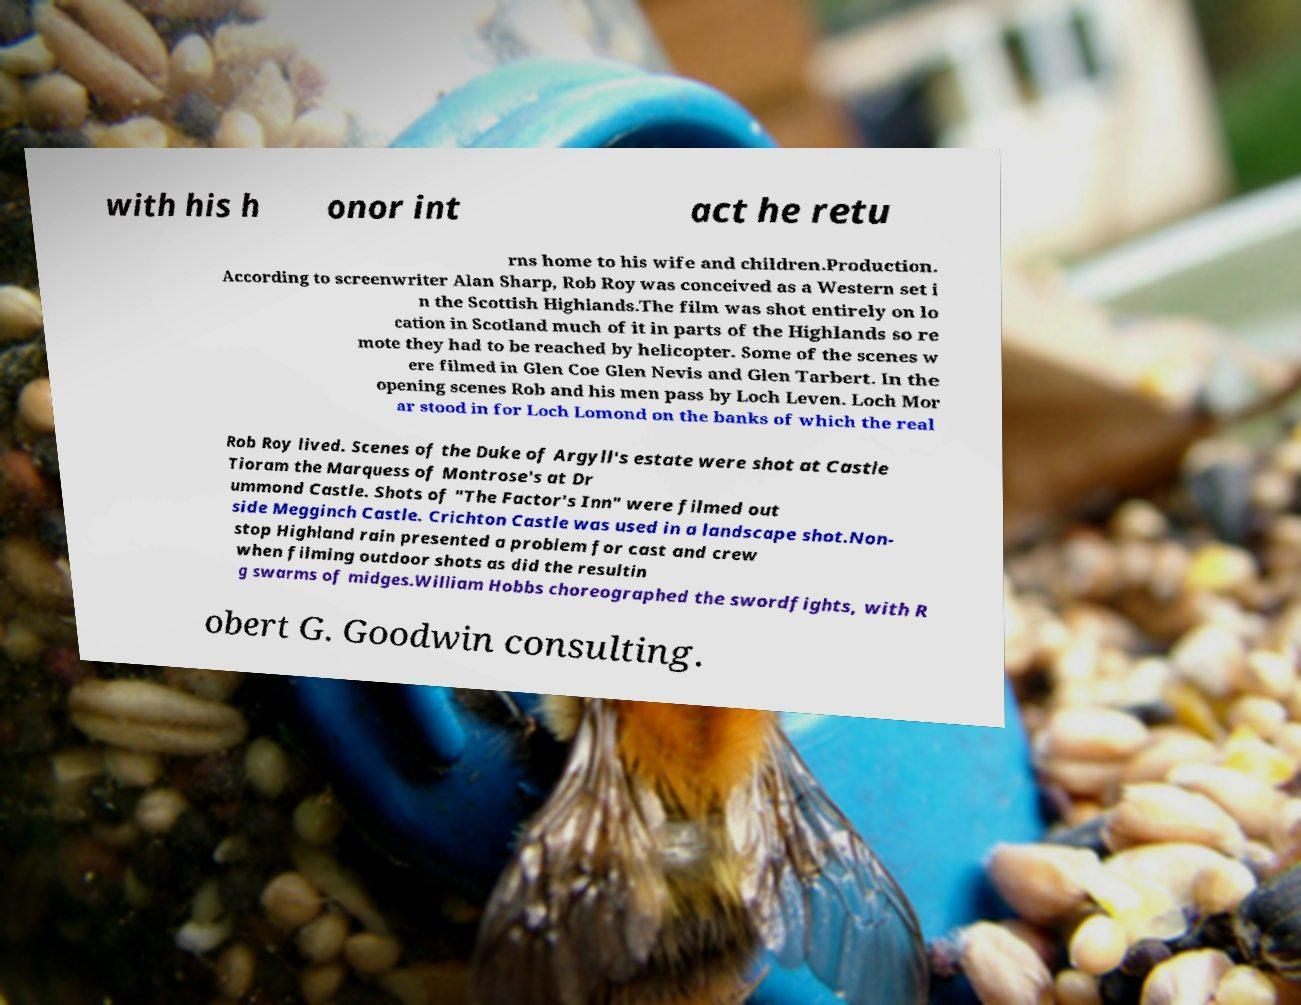Could you assist in decoding the text presented in this image and type it out clearly? with his h onor int act he retu rns home to his wife and children.Production. According to screenwriter Alan Sharp, Rob Roy was conceived as a Western set i n the Scottish Highlands.The film was shot entirely on lo cation in Scotland much of it in parts of the Highlands so re mote they had to be reached by helicopter. Some of the scenes w ere filmed in Glen Coe Glen Nevis and Glen Tarbert. In the opening scenes Rob and his men pass by Loch Leven. Loch Mor ar stood in for Loch Lomond on the banks of which the real Rob Roy lived. Scenes of the Duke of Argyll's estate were shot at Castle Tioram the Marquess of Montrose's at Dr ummond Castle. Shots of "The Factor's Inn" were filmed out side Megginch Castle. Crichton Castle was used in a landscape shot.Non- stop Highland rain presented a problem for cast and crew when filming outdoor shots as did the resultin g swarms of midges.William Hobbs choreographed the swordfights, with R obert G. Goodwin consulting. 